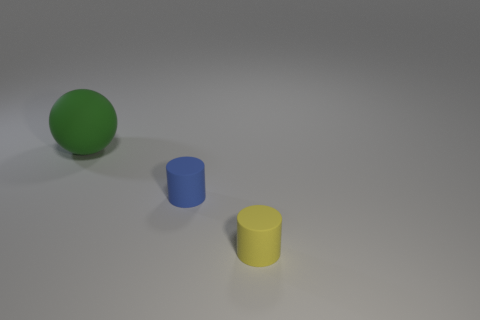Add 1 small yellow things. How many objects exist? 4 Subtract all balls. How many objects are left? 2 Subtract all small yellow cylinders. Subtract all green matte objects. How many objects are left? 1 Add 1 small yellow objects. How many small yellow objects are left? 2 Add 2 big purple shiny objects. How many big purple shiny objects exist? 2 Subtract 0 yellow spheres. How many objects are left? 3 